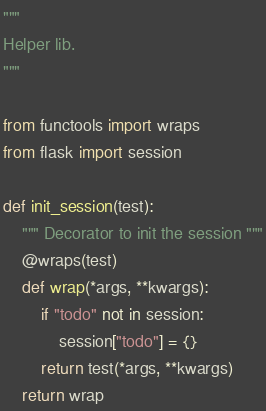Convert code to text. <code><loc_0><loc_0><loc_500><loc_500><_Python_>"""
Helper lib.
"""

from functools import wraps
from flask import session

def init_session(test):
    """ Decorator to init the session """
    @wraps(test)
    def wrap(*args, **kwargs):
        if "todo" not in session:
            session["todo"] = {}
        return test(*args, **kwargs)
    return wrap
</code> 